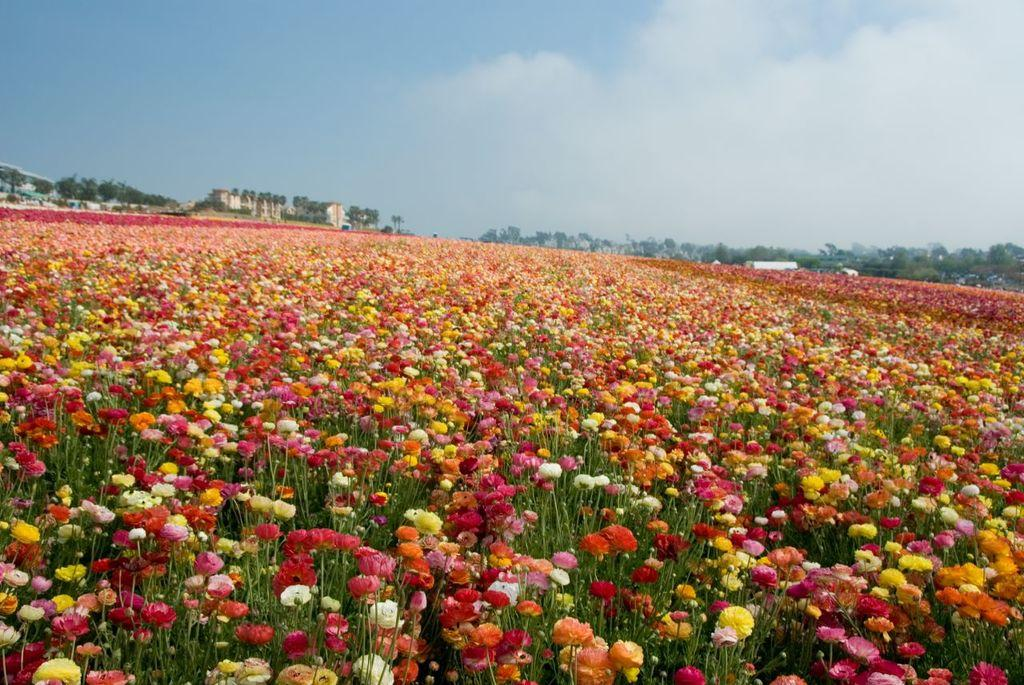What is the main subject of the image? There is a field of colorful flowers in the image. What can be seen in the background of the image? There are trees in the background of the image. What color is the sky in the image? The sky is blue in color. What else can be seen in the sky? There are clouds visible in the sky. Where is the office located in the image? There is no office present in the image; it features a field of colorful flowers, trees, and a blue sky with clouds. 